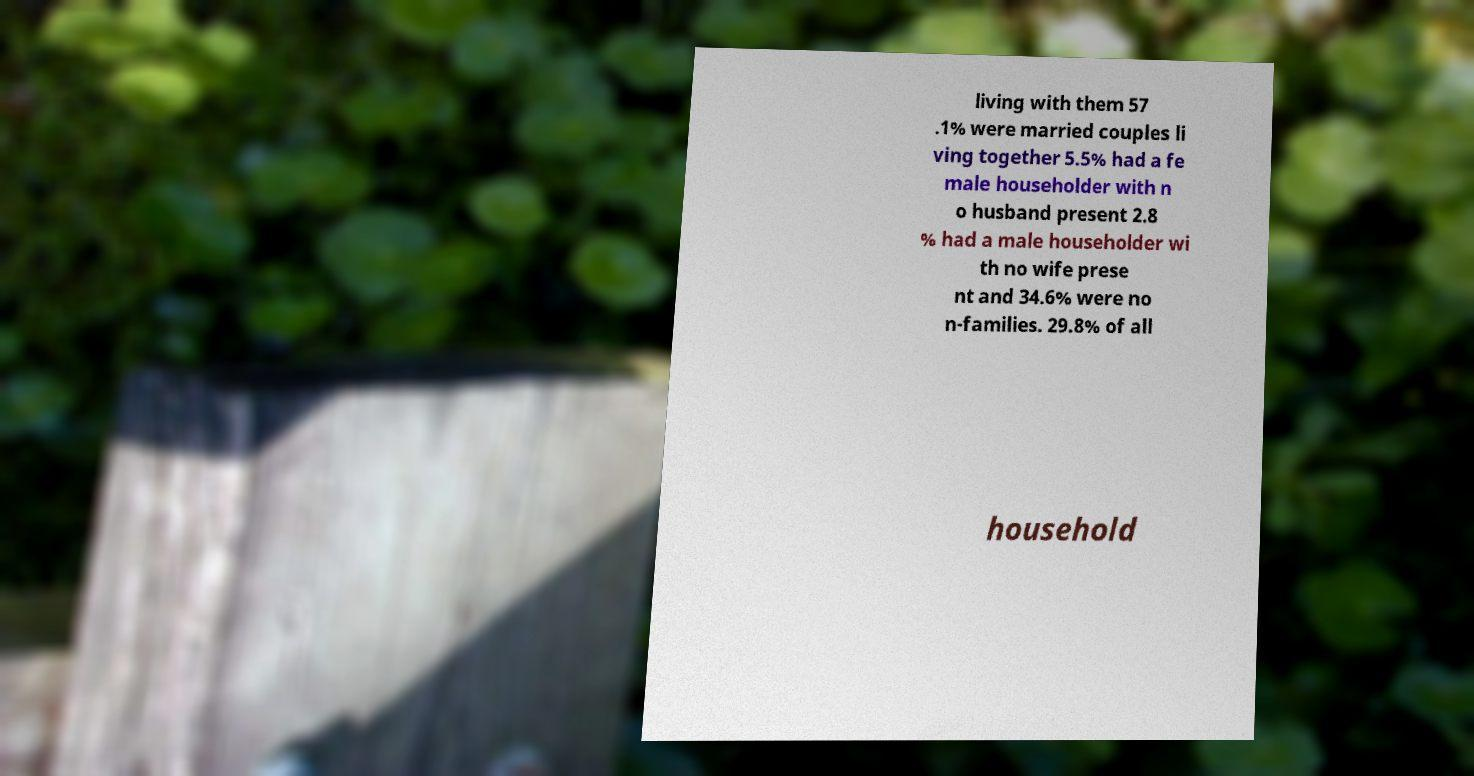What messages or text are displayed in this image? I need them in a readable, typed format. living with them 57 .1% were married couples li ving together 5.5% had a fe male householder with n o husband present 2.8 % had a male householder wi th no wife prese nt and 34.6% were no n-families. 29.8% of all household 